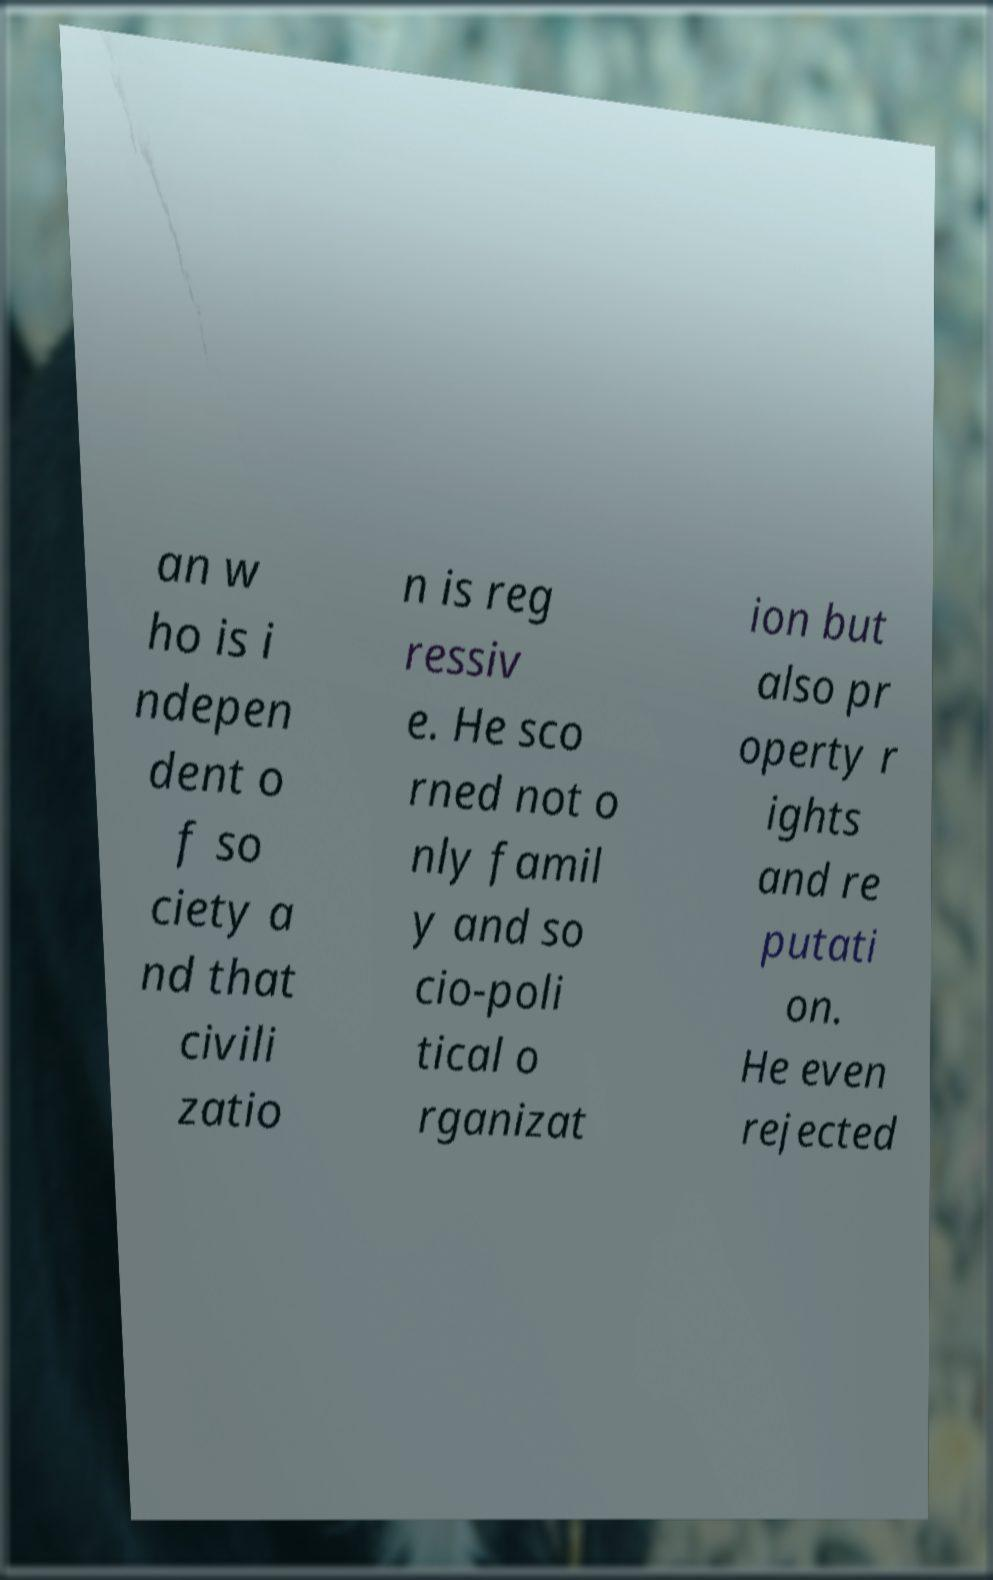Could you assist in decoding the text presented in this image and type it out clearly? an w ho is i ndepen dent o f so ciety a nd that civili zatio n is reg ressiv e. He sco rned not o nly famil y and so cio-poli tical o rganizat ion but also pr operty r ights and re putati on. He even rejected 